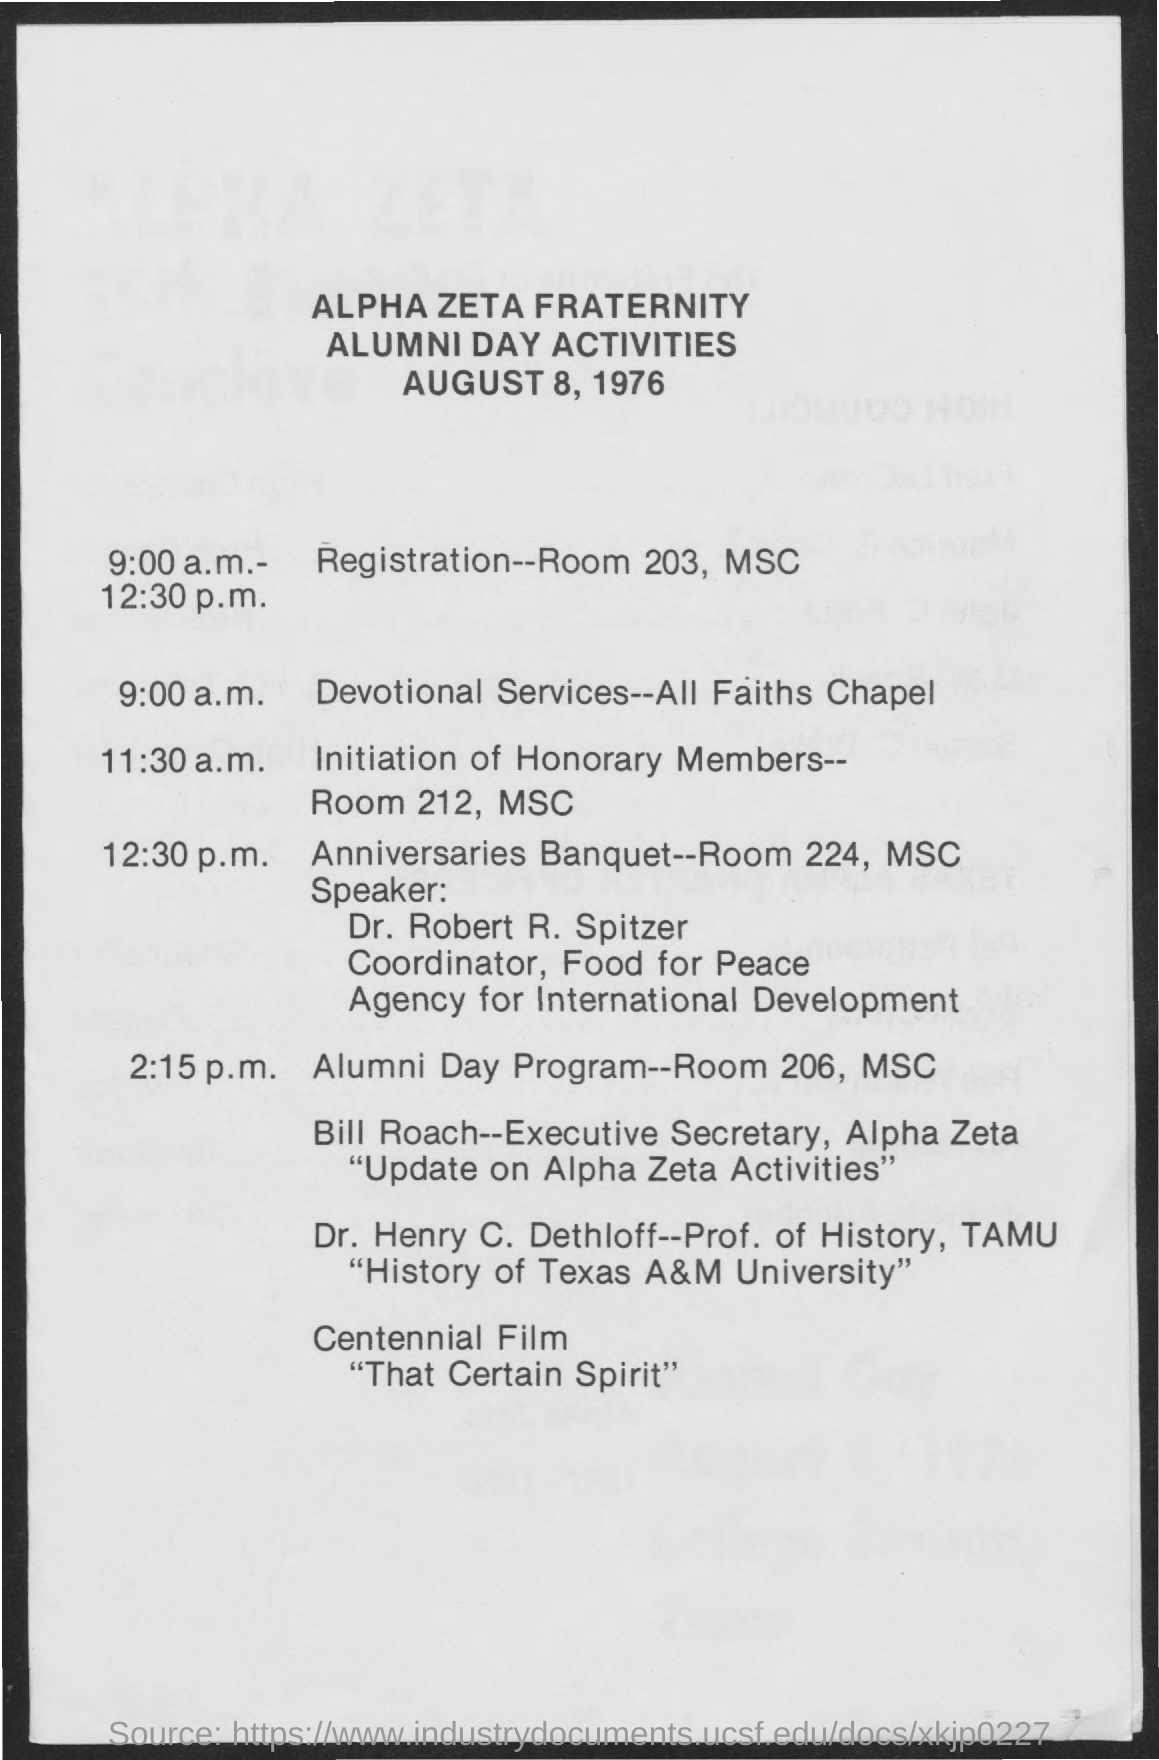Mention a couple of crucial points in this snapshot. The location of devotional services is the All Faiths Chapel. The document indicates that the date is August 8, 1976. The initiation of honorary members will take place in room 212 of the MSC. The registration will take place in ROOM 203 of the MSC. 